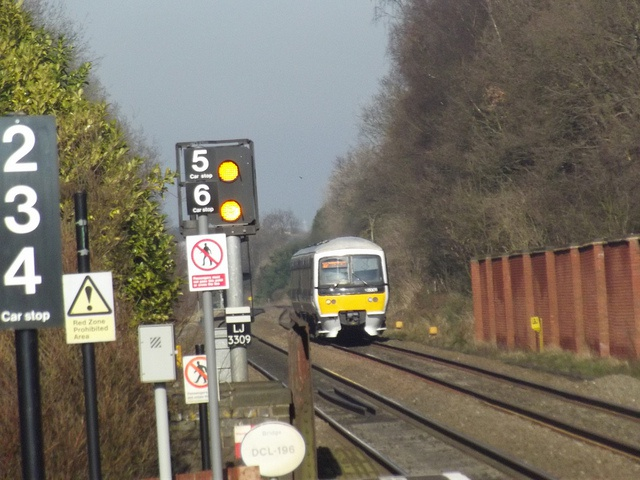Describe the objects in this image and their specific colors. I can see train in darkgreen, gray, darkgray, lightgray, and black tones and traffic light in darkgreen, gray, darkgray, white, and yellow tones in this image. 